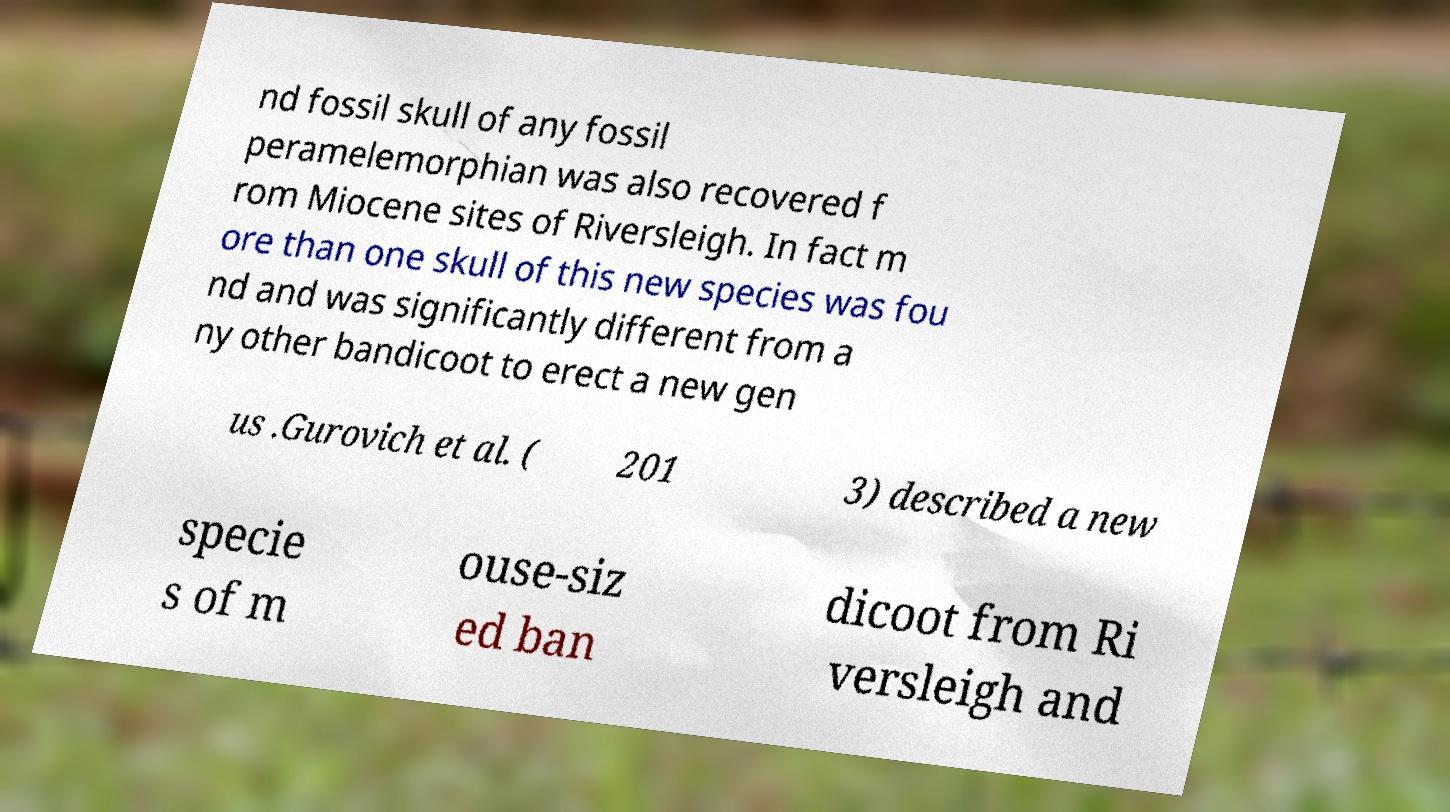For documentation purposes, I need the text within this image transcribed. Could you provide that? nd fossil skull of any fossil peramelemorphian was also recovered f rom Miocene sites of Riversleigh. In fact m ore than one skull of this new species was fou nd and was significantly different from a ny other bandicoot to erect a new gen us .Gurovich et al. ( 201 3) described a new specie s of m ouse-siz ed ban dicoot from Ri versleigh and 